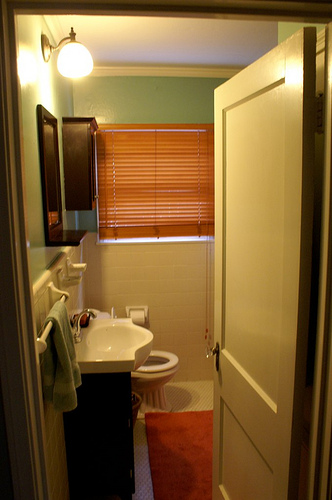Where is the sink located relative to the toilet? The sink is positioned to the left of the toilet, making it easily accessible for users before or after using the toilet. 